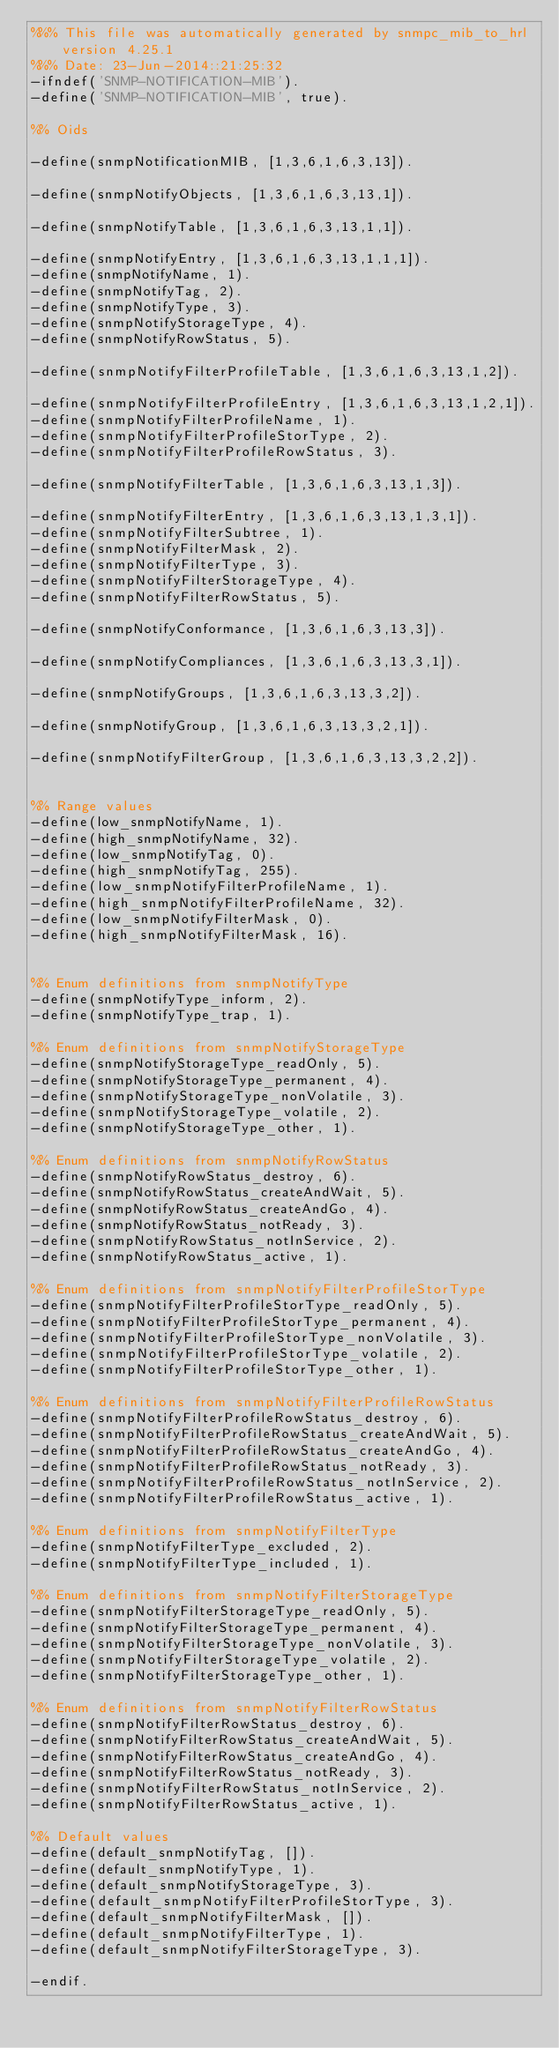<code> <loc_0><loc_0><loc_500><loc_500><_Erlang_>%%% This file was automatically generated by snmpc_mib_to_hrl version 4.25.1
%%% Date: 23-Jun-2014::21:25:32
-ifndef('SNMP-NOTIFICATION-MIB').
-define('SNMP-NOTIFICATION-MIB', true).

%% Oids

-define(snmpNotificationMIB, [1,3,6,1,6,3,13]).

-define(snmpNotifyObjects, [1,3,6,1,6,3,13,1]).

-define(snmpNotifyTable, [1,3,6,1,6,3,13,1,1]).

-define(snmpNotifyEntry, [1,3,6,1,6,3,13,1,1,1]).
-define(snmpNotifyName, 1).
-define(snmpNotifyTag, 2).
-define(snmpNotifyType, 3).
-define(snmpNotifyStorageType, 4).
-define(snmpNotifyRowStatus, 5).

-define(snmpNotifyFilterProfileTable, [1,3,6,1,6,3,13,1,2]).

-define(snmpNotifyFilterProfileEntry, [1,3,6,1,6,3,13,1,2,1]).
-define(snmpNotifyFilterProfileName, 1).
-define(snmpNotifyFilterProfileStorType, 2).
-define(snmpNotifyFilterProfileRowStatus, 3).

-define(snmpNotifyFilterTable, [1,3,6,1,6,3,13,1,3]).

-define(snmpNotifyFilterEntry, [1,3,6,1,6,3,13,1,3,1]).
-define(snmpNotifyFilterSubtree, 1).
-define(snmpNotifyFilterMask, 2).
-define(snmpNotifyFilterType, 3).
-define(snmpNotifyFilterStorageType, 4).
-define(snmpNotifyFilterRowStatus, 5).

-define(snmpNotifyConformance, [1,3,6,1,6,3,13,3]).

-define(snmpNotifyCompliances, [1,3,6,1,6,3,13,3,1]).

-define(snmpNotifyGroups, [1,3,6,1,6,3,13,3,2]).

-define(snmpNotifyGroup, [1,3,6,1,6,3,13,3,2,1]).

-define(snmpNotifyFilterGroup, [1,3,6,1,6,3,13,3,2,2]).


%% Range values
-define(low_snmpNotifyName, 1).
-define(high_snmpNotifyName, 32).
-define(low_snmpNotifyTag, 0).
-define(high_snmpNotifyTag, 255).
-define(low_snmpNotifyFilterProfileName, 1).
-define(high_snmpNotifyFilterProfileName, 32).
-define(low_snmpNotifyFilterMask, 0).
-define(high_snmpNotifyFilterMask, 16).


%% Enum definitions from snmpNotifyType
-define(snmpNotifyType_inform, 2).
-define(snmpNotifyType_trap, 1).

%% Enum definitions from snmpNotifyStorageType
-define(snmpNotifyStorageType_readOnly, 5).
-define(snmpNotifyStorageType_permanent, 4).
-define(snmpNotifyStorageType_nonVolatile, 3).
-define(snmpNotifyStorageType_volatile, 2).
-define(snmpNotifyStorageType_other, 1).

%% Enum definitions from snmpNotifyRowStatus
-define(snmpNotifyRowStatus_destroy, 6).
-define(snmpNotifyRowStatus_createAndWait, 5).
-define(snmpNotifyRowStatus_createAndGo, 4).
-define(snmpNotifyRowStatus_notReady, 3).
-define(snmpNotifyRowStatus_notInService, 2).
-define(snmpNotifyRowStatus_active, 1).

%% Enum definitions from snmpNotifyFilterProfileStorType
-define(snmpNotifyFilterProfileStorType_readOnly, 5).
-define(snmpNotifyFilterProfileStorType_permanent, 4).
-define(snmpNotifyFilterProfileStorType_nonVolatile, 3).
-define(snmpNotifyFilterProfileStorType_volatile, 2).
-define(snmpNotifyFilterProfileStorType_other, 1).

%% Enum definitions from snmpNotifyFilterProfileRowStatus
-define(snmpNotifyFilterProfileRowStatus_destroy, 6).
-define(snmpNotifyFilterProfileRowStatus_createAndWait, 5).
-define(snmpNotifyFilterProfileRowStatus_createAndGo, 4).
-define(snmpNotifyFilterProfileRowStatus_notReady, 3).
-define(snmpNotifyFilterProfileRowStatus_notInService, 2).
-define(snmpNotifyFilterProfileRowStatus_active, 1).

%% Enum definitions from snmpNotifyFilterType
-define(snmpNotifyFilterType_excluded, 2).
-define(snmpNotifyFilterType_included, 1).

%% Enum definitions from snmpNotifyFilterStorageType
-define(snmpNotifyFilterStorageType_readOnly, 5).
-define(snmpNotifyFilterStorageType_permanent, 4).
-define(snmpNotifyFilterStorageType_nonVolatile, 3).
-define(snmpNotifyFilterStorageType_volatile, 2).
-define(snmpNotifyFilterStorageType_other, 1).

%% Enum definitions from snmpNotifyFilterRowStatus
-define(snmpNotifyFilterRowStatus_destroy, 6).
-define(snmpNotifyFilterRowStatus_createAndWait, 5).
-define(snmpNotifyFilterRowStatus_createAndGo, 4).
-define(snmpNotifyFilterRowStatus_notReady, 3).
-define(snmpNotifyFilterRowStatus_notInService, 2).
-define(snmpNotifyFilterRowStatus_active, 1).

%% Default values
-define(default_snmpNotifyTag, []).
-define(default_snmpNotifyType, 1).
-define(default_snmpNotifyStorageType, 3).
-define(default_snmpNotifyFilterProfileStorType, 3).
-define(default_snmpNotifyFilterMask, []).
-define(default_snmpNotifyFilterType, 1).
-define(default_snmpNotifyFilterStorageType, 3).

-endif.
</code> 